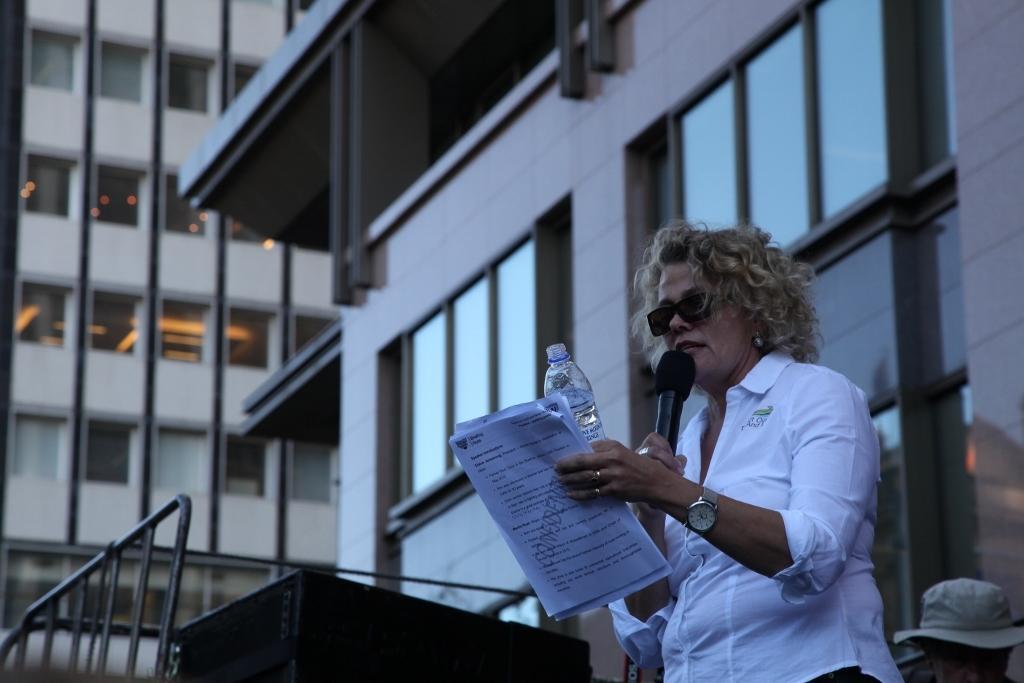How would you summarize this image in a sentence or two? This picture is clicked outside the city. Woman standing on the right bottom of the picture is holding papers in her hands. She is even holding water bottle in her hands and she is wearing goggles and watch. She is holding microphone and talking on it. Behind her, we see a person wearing cap. To the right of her, we see a table and behind her, we see a building and to the right on the right, of the picture we see building with many windows. 